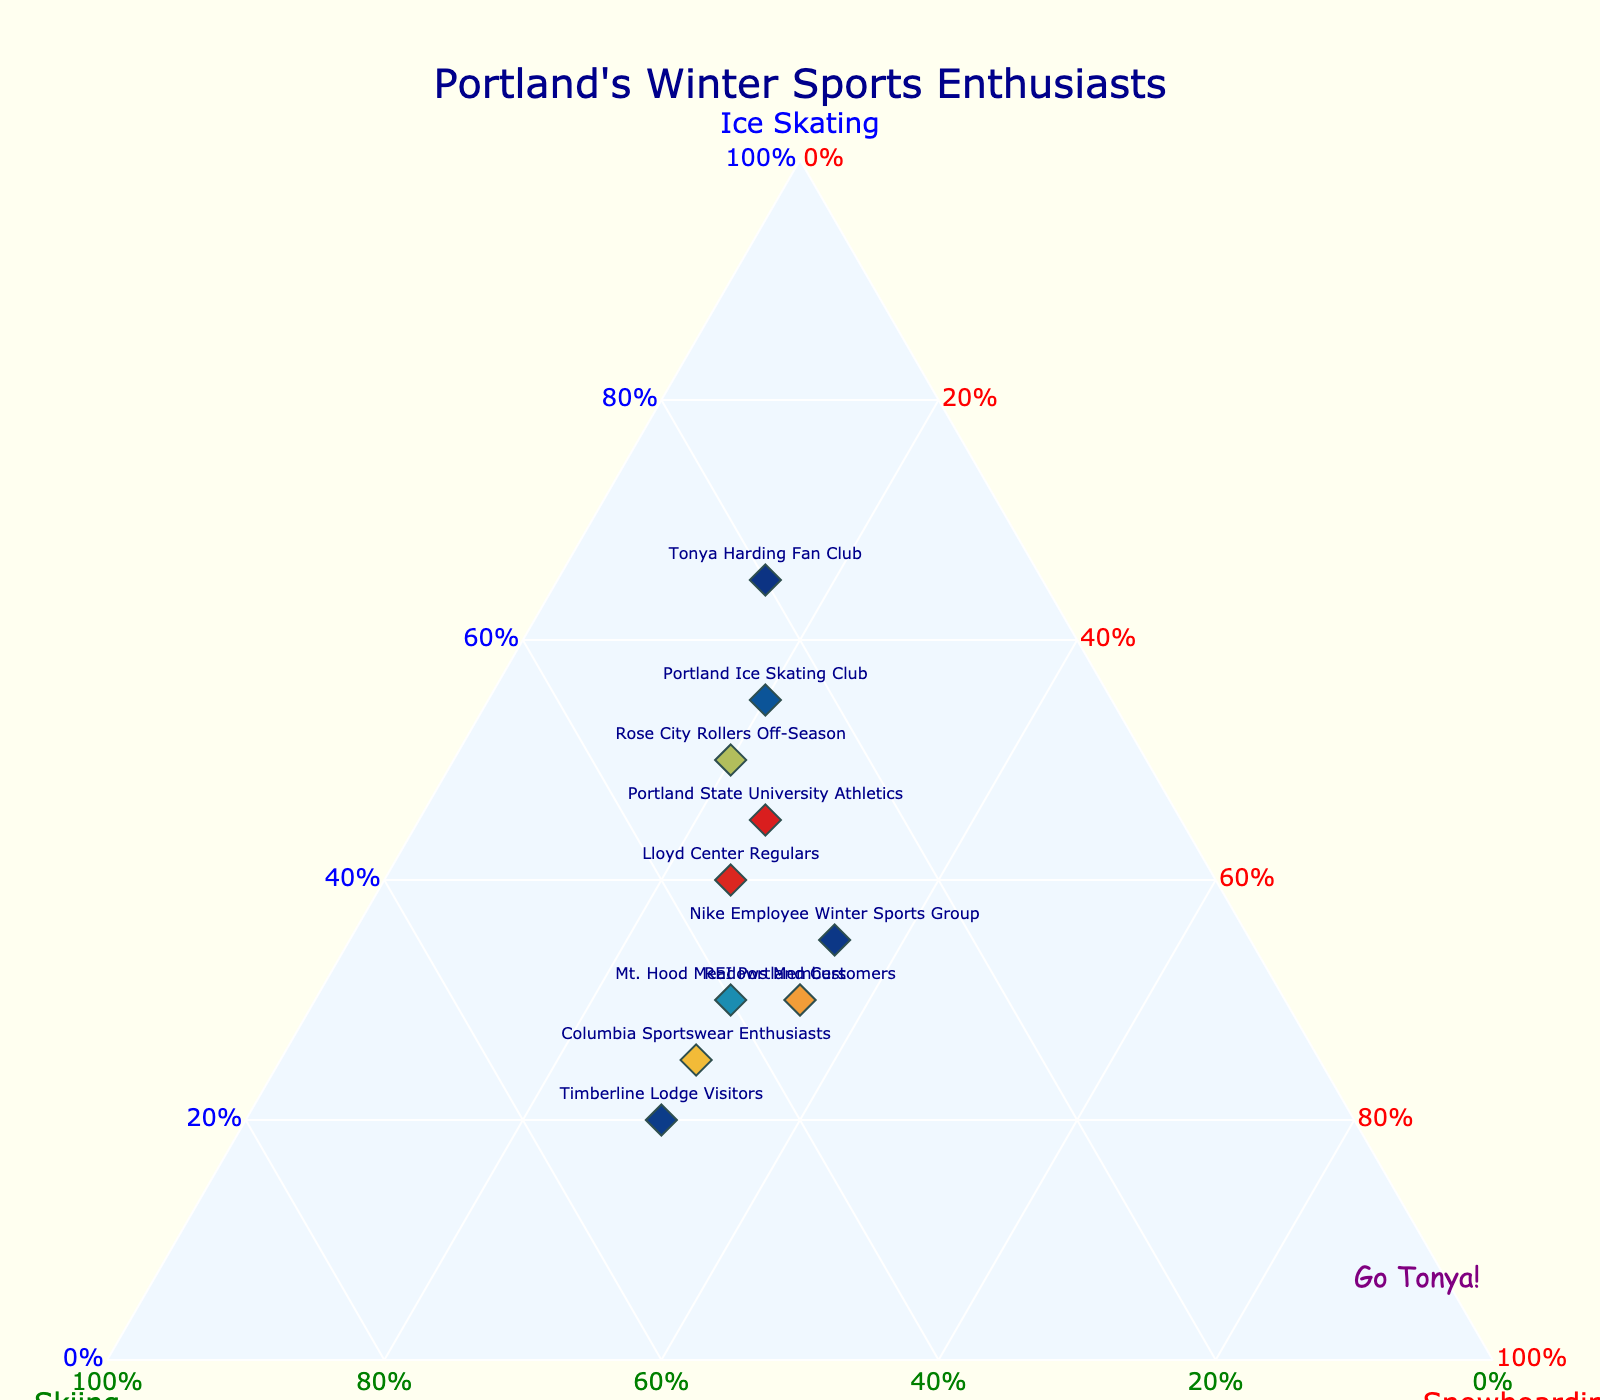How many total groups are represented in the plot? The plot includes labels for different groups. By counting these labels, we can determine the number of distinct groups represented.
Answer: 10 Which group has the highest percentage of ice skating enthusiasts? By examining the ternary plot, look for the group with the highest value along the Ice Skating axis (a-axis). The Tonya Harding Fan Club has 65% in Ice Skating.
Answer: Tonya Harding Fan Club Which group has the highest percentage for skiing? Observing the ternary plot, check for the group situated highest along the Skiing axis (b-axis). Timberline Lodge Visitors has the highest value with 50%.
Answer: Timberline Lodge Visitors Which groups have equal percentages for snowboarding? On the plot, look for groups that have the same value along the Snowboarding axis (c-axis). Both Nike Employee Winter Sports Group and REI Portland Customers have 35% in Snowboarding.
Answer: Nike Employee Winter Sports Group, REI Portland Customers What's the sum of the ice skating percentages for Portland Ice Skating Club and Rose City Rollers Off-Season? According to the plot, Portland Ice Skating Club has 55% and Rose City Rollers Off-Season has 50% for Ice Skating. Therefore, the sum is 55 + 50.
Answer: 105% Which group is closest to having an equal preference among all three activities? On a ternary plot, closer proximity to the center indicates a more balanced preference. Examining the plot, Mt. Hood Meadows Members with 30% Ice Skating, 40% Skiing, and 30% Snowboarding is closest to the center.
Answer: Mt. Hood Meadows Members Compare the percentages of ice skating between Tonya Harding Fan Club and Columbia Sportswear Enthusiasts. Which one has a higher percentage, and by how much? Tonya Harding Fan Club has 65% and Columbia Sportswear Enthusiasts have 25%. The difference is 65 - 25.
Answer: Tonya Harding Fan Club by 40% What is the median percentage for skiing among all groups? The skiing percentages of all groups are: 20, 35, 40, 50, 25, 30, 30, 45, 30, 35. Sorting these values gives: 20, 25, 30, 30, 30, 35, 35, 40, 45, 50. The median is the average of the 5th and 6th values: (30 + 35) / 2.
Answer: 32.5% Which group has the lowest percentage in snowboarding, and what is that percentage? Looking at the c-axis for Snowboarding, the group with the lowest value is Tonya Harding Fan Club with 15%.
Answer: Tonya Harding Fan Club, 15% How does the percentage for skiing in Lloyd Center Regulars compare to the percentage for ice skating in REI Portland Customers? Lloyd Center Regulars have 35% in Skiing, and REI Portland Customers have 30% in Ice Skating. Therefore, the skiing percentage is higher.
Answer: Skiing in Lloyd Center Regulars is higher by 5% 